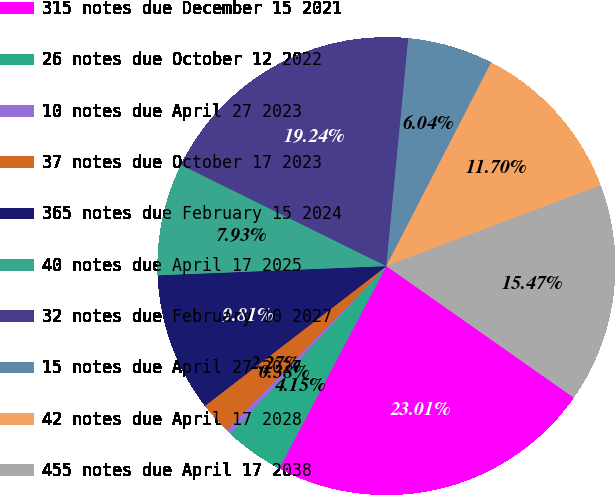<chart> <loc_0><loc_0><loc_500><loc_500><pie_chart><fcel>315 notes due December 15 2021<fcel>26 notes due October 12 2022<fcel>10 notes due April 27 2023<fcel>37 notes due October 17 2023<fcel>365 notes due February 15 2024<fcel>40 notes due April 17 2025<fcel>32 notes due February 10 2027<fcel>15 notes due April 27 2027<fcel>42 notes due April 17 2028<fcel>455 notes due April 17 2038<nl><fcel>23.01%<fcel>4.15%<fcel>0.38%<fcel>2.27%<fcel>9.81%<fcel>7.93%<fcel>19.24%<fcel>6.04%<fcel>11.7%<fcel>15.47%<nl></chart> 